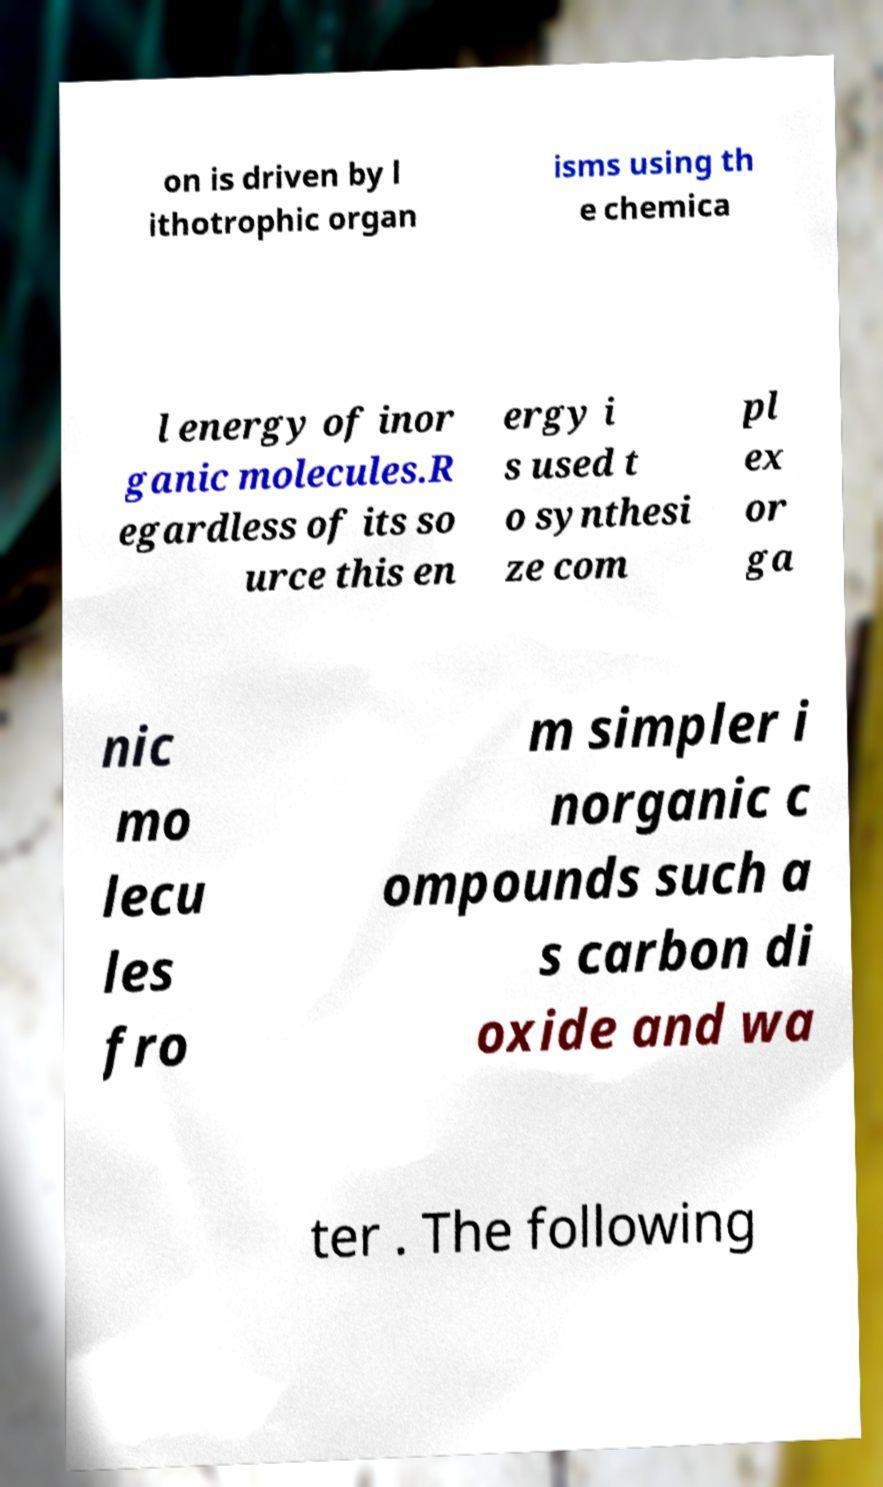For documentation purposes, I need the text within this image transcribed. Could you provide that? on is driven by l ithotrophic organ isms using th e chemica l energy of inor ganic molecules.R egardless of its so urce this en ergy i s used t o synthesi ze com pl ex or ga nic mo lecu les fro m simpler i norganic c ompounds such a s carbon di oxide and wa ter . The following 